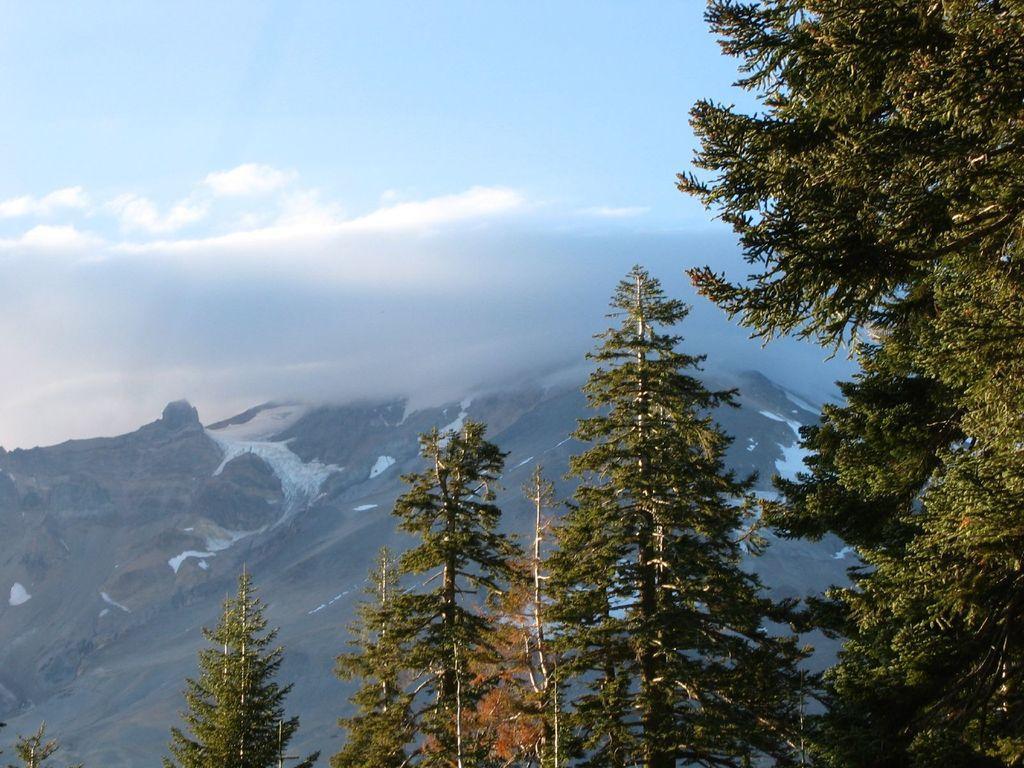Describe this image in one or two sentences. In this picture I can see trees, there are snowy mountains, and in the background there is sky. 